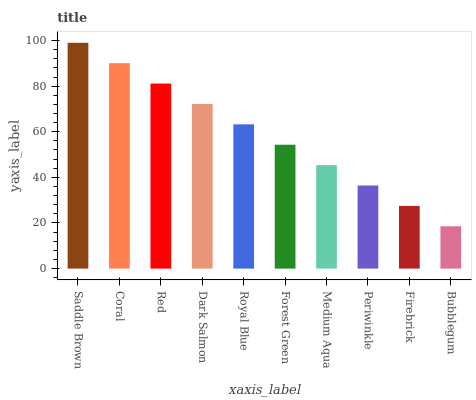Is Bubblegum the minimum?
Answer yes or no. Yes. Is Saddle Brown the maximum?
Answer yes or no. Yes. Is Coral the minimum?
Answer yes or no. No. Is Coral the maximum?
Answer yes or no. No. Is Saddle Brown greater than Coral?
Answer yes or no. Yes. Is Coral less than Saddle Brown?
Answer yes or no. Yes. Is Coral greater than Saddle Brown?
Answer yes or no. No. Is Saddle Brown less than Coral?
Answer yes or no. No. Is Royal Blue the high median?
Answer yes or no. Yes. Is Forest Green the low median?
Answer yes or no. Yes. Is Medium Aqua the high median?
Answer yes or no. No. Is Red the low median?
Answer yes or no. No. 